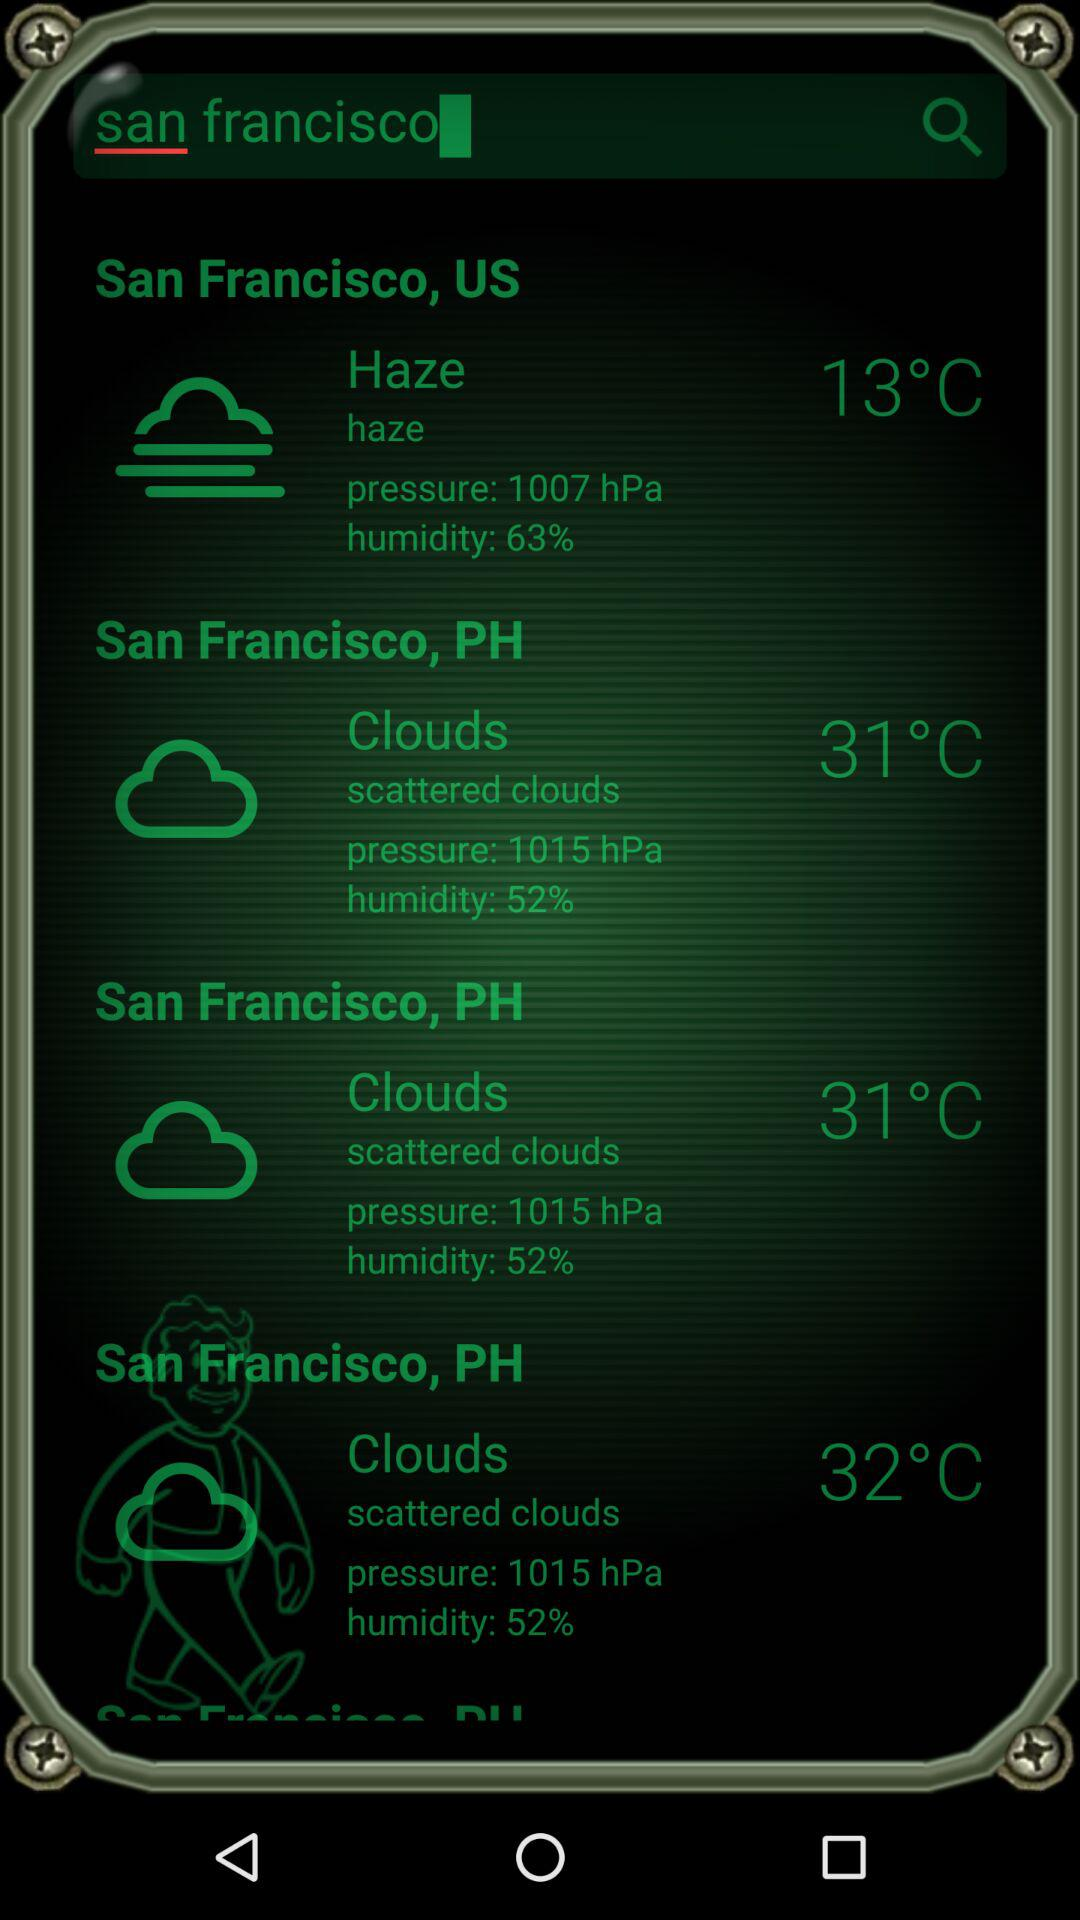31 degrees celcius is given for which option? The temperature of 31°C is given for San Francisco, PH. 